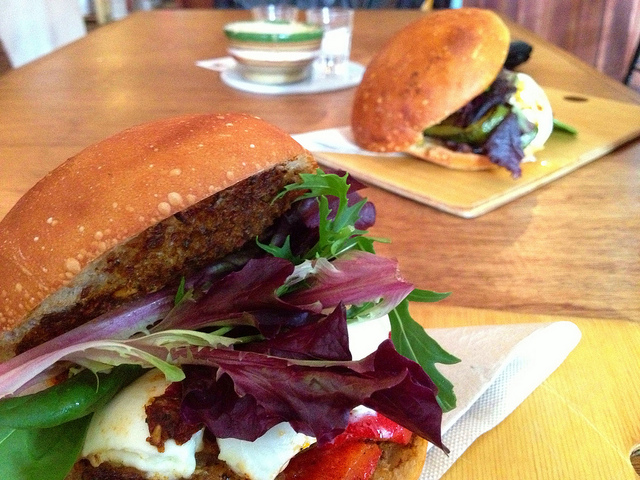Can you create a poem inspired by the image of the sandwiches? In a sunlit bistro, where stories unfold,
Lie sandwiches laden, treasures to behold.
Golden buns warm from the oven’s embrace,
A masterpiece crafted with delicate grace.
Layers of greens, so fresh and so bright,
A medley of colors in joyous delight.
Grilled veggies' whispers, flavors in bloom,
A slice of cheese melts, dispelling all gloom.
From farm to table, their journey composed,
A tale of the harvest, in harmony posed.
In each tender bite, a story’s unfurled,
Uniting us all, through meals in this world. Describe a realistic scenario where someone enjoys these sandwiches. A couple, enjoying a lazy Saturday afternoon, decides to visit their favorite bistro. They find a cozy corner table with sunlight streaming through the window, casting a warm glow over everything. After chatting with the friendly staff, they order the bistro's famed sandwiches. As the sandwiches arrive, the enticing aroma fills the air, and their eyes widen in delight. With a shared smile, they dig in, savoring each bite filled with flavors and textures. Between bites, they share stories and laughter, feeling absolutely content and joyful, creating a perfect moment together.  Imagine these sandwiches were part of a grand feast. What kind of event would it be? These sandwiches would be the stars of a chic garden party hosted in a picturesque backyard, adorned with fairy lights and rustic decor. Guests dressed in elegant summer attire would mingle, relish in live acoustic music, and enjoy an array of gourmet delights. The atmosphere would ooze sophistication yet maintain a casual charm, with the sandwiches being a much-anticipated highlight of the culinary spread. Each sumptuous bite would spark conversations about fresh ingredients, culinary creativity, and the joys of sharing exquisite food. This gathering would be a celebratory ode to good food and great company, nestled in the serene embrace of nature. Now, tell me a very creative story involving these sandwiches and a magical element. Deep in the heart of Enchanted Grove, where the whispers of the forest held ancient secrets, there existed a mystical bistro known for its magical sandwiches. One fair morning, Luna, the bistro’s chef – a gifted enchantress, prepared her renowned sandwiches with ingredients bestowed by the forest itself. The lettuce shimmered with dewdrop magic, the peppers roasted by dragonfire, and the buns blessed by the wise old oak. As each sandwich was crafted, Luna cast a spell of happiness and wonder within them. When patrons ventured into the bistro and tasted these enchanted sandwiches, they were transported to realms of their heart's desires. Some found themselves dancing with fairies, others sat in council with ancient spirits learning forgotten wisdom, and a few even rode unicorns across moonlit meadows. Each bite was a passage to a world of dreams, brought to life by the magic weaved into every layer of the sandwich. And thus, in Enchanted Grove, the humble sandwich became a gateway to the wonders of imagination. 